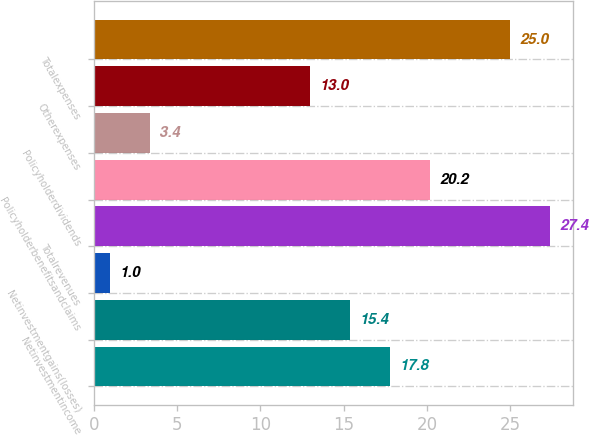<chart> <loc_0><loc_0><loc_500><loc_500><bar_chart><ecel><fcel>Netinvestmentincome<fcel>Netinvestmentgains(losses)<fcel>Totalrevenues<fcel>Policyholderbenefitsandclaims<fcel>Policyholderdividends<fcel>Otherexpenses<fcel>Totalexpenses<nl><fcel>17.8<fcel>15.4<fcel>1<fcel>27.4<fcel>20.2<fcel>3.4<fcel>13<fcel>25<nl></chart> 